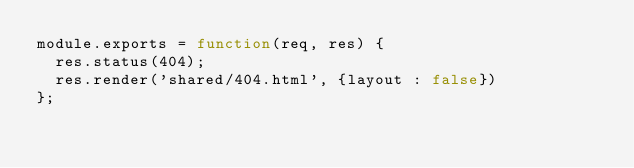Convert code to text. <code><loc_0><loc_0><loc_500><loc_500><_JavaScript_>module.exports = function(req, res) {
  res.status(404);
  res.render('shared/404.html', {layout : false})
};
</code> 